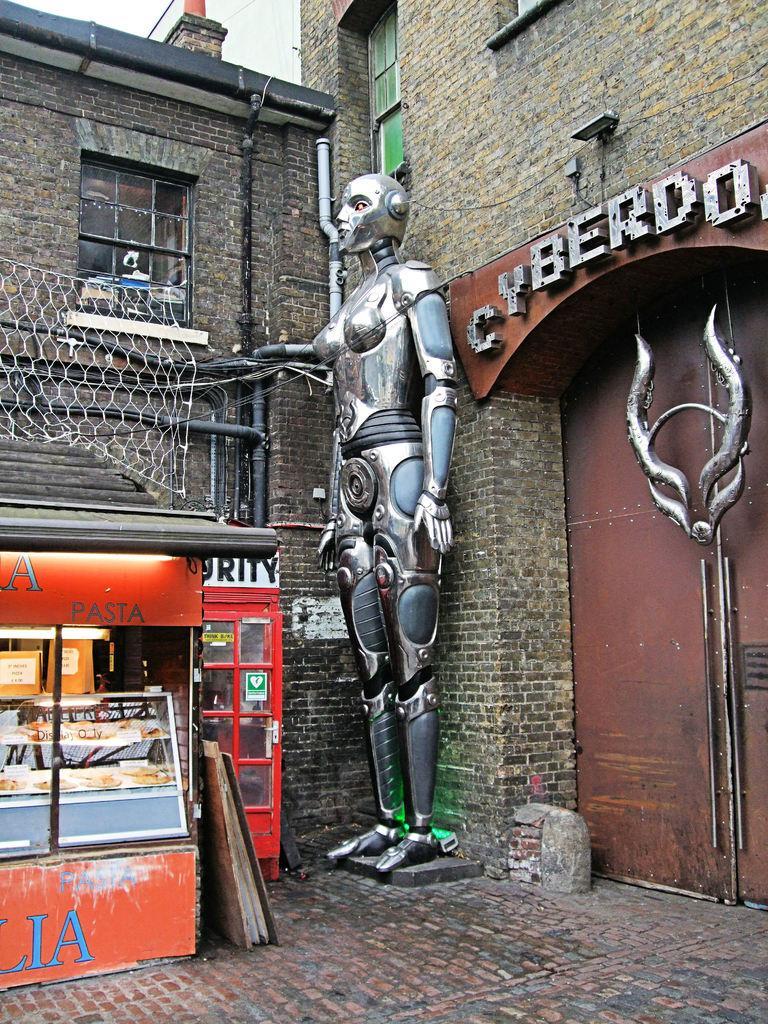Describe this image in one or two sentences. In this image we can see brick road, food store, telephone booth, robot statue, gate, name board, brick buildings, pipes, wires and sky in the background. 